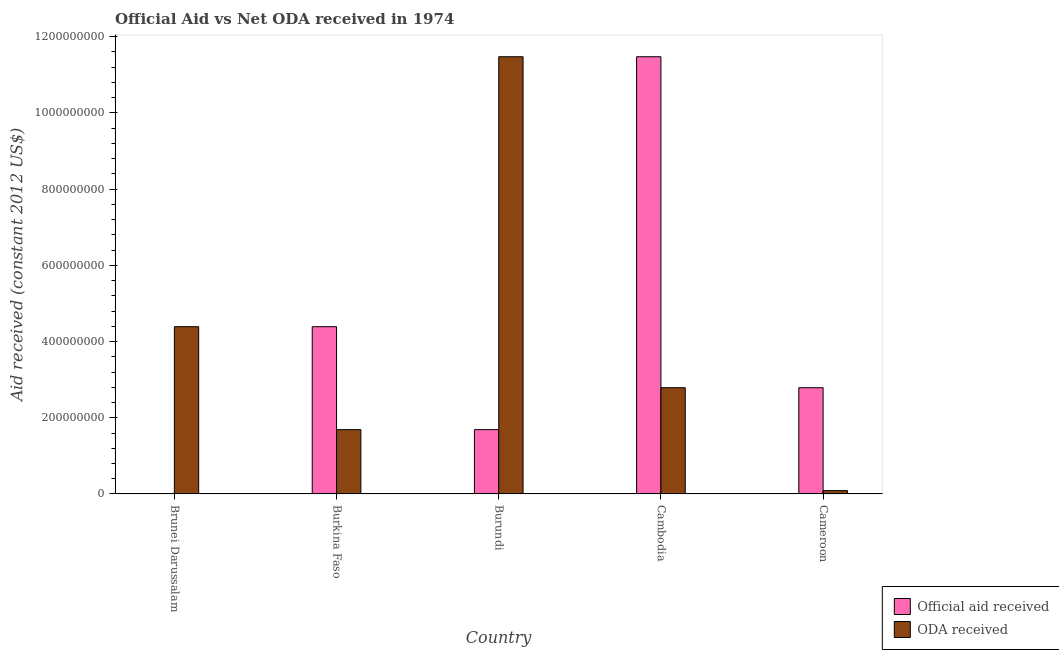How many different coloured bars are there?
Make the answer very short. 2. Are the number of bars per tick equal to the number of legend labels?
Keep it short and to the point. Yes. Are the number of bars on each tick of the X-axis equal?
Your answer should be compact. Yes. How many bars are there on the 5th tick from the left?
Ensure brevity in your answer.  2. What is the label of the 2nd group of bars from the left?
Provide a succinct answer. Burkina Faso. What is the official aid received in Cambodia?
Ensure brevity in your answer.  1.15e+09. Across all countries, what is the maximum oda received?
Keep it short and to the point. 1.15e+09. Across all countries, what is the minimum oda received?
Your response must be concise. 8.77e+06. In which country was the oda received maximum?
Keep it short and to the point. Burundi. In which country was the oda received minimum?
Provide a succinct answer. Cameroon. What is the total oda received in the graph?
Your answer should be compact. 2.04e+09. What is the difference between the official aid received in Burundi and that in Cameroon?
Make the answer very short. -1.10e+08. What is the difference between the official aid received in Cambodia and the oda received in Burundi?
Give a very brief answer. 0. What is the average official aid received per country?
Provide a succinct answer. 4.07e+08. What is the difference between the oda received and official aid received in Burundi?
Provide a succinct answer. 9.79e+08. In how many countries, is the official aid received greater than 880000000 US$?
Give a very brief answer. 1. What is the ratio of the oda received in Burkina Faso to that in Burundi?
Ensure brevity in your answer.  0.15. What is the difference between the highest and the second highest official aid received?
Your answer should be compact. 7.08e+08. What is the difference between the highest and the lowest oda received?
Make the answer very short. 1.14e+09. In how many countries, is the oda received greater than the average oda received taken over all countries?
Keep it short and to the point. 2. What does the 1st bar from the left in Cameroon represents?
Keep it short and to the point. Official aid received. What does the 1st bar from the right in Cambodia represents?
Make the answer very short. ODA received. How many countries are there in the graph?
Make the answer very short. 5. Are the values on the major ticks of Y-axis written in scientific E-notation?
Make the answer very short. No. Where does the legend appear in the graph?
Offer a very short reply. Bottom right. How many legend labels are there?
Offer a terse response. 2. What is the title of the graph?
Keep it short and to the point. Official Aid vs Net ODA received in 1974 . Does "Formally registered" appear as one of the legend labels in the graph?
Make the answer very short. No. What is the label or title of the X-axis?
Provide a succinct answer. Country. What is the label or title of the Y-axis?
Your response must be concise. Aid received (constant 2012 US$). What is the Aid received (constant 2012 US$) in Official aid received in Brunei Darussalam?
Your response must be concise. 7.80e+05. What is the Aid received (constant 2012 US$) in ODA received in Brunei Darussalam?
Ensure brevity in your answer.  4.39e+08. What is the Aid received (constant 2012 US$) in Official aid received in Burkina Faso?
Your answer should be compact. 4.39e+08. What is the Aid received (constant 2012 US$) of ODA received in Burkina Faso?
Your answer should be compact. 1.69e+08. What is the Aid received (constant 2012 US$) in Official aid received in Burundi?
Your response must be concise. 1.69e+08. What is the Aid received (constant 2012 US$) of ODA received in Burundi?
Offer a terse response. 1.15e+09. What is the Aid received (constant 2012 US$) of Official aid received in Cambodia?
Make the answer very short. 1.15e+09. What is the Aid received (constant 2012 US$) in ODA received in Cambodia?
Keep it short and to the point. 2.79e+08. What is the Aid received (constant 2012 US$) of Official aid received in Cameroon?
Offer a very short reply. 2.79e+08. What is the Aid received (constant 2012 US$) of ODA received in Cameroon?
Ensure brevity in your answer.  8.77e+06. Across all countries, what is the maximum Aid received (constant 2012 US$) of Official aid received?
Your answer should be very brief. 1.15e+09. Across all countries, what is the maximum Aid received (constant 2012 US$) of ODA received?
Keep it short and to the point. 1.15e+09. Across all countries, what is the minimum Aid received (constant 2012 US$) of Official aid received?
Give a very brief answer. 7.80e+05. Across all countries, what is the minimum Aid received (constant 2012 US$) in ODA received?
Your response must be concise. 8.77e+06. What is the total Aid received (constant 2012 US$) of Official aid received in the graph?
Offer a terse response. 2.04e+09. What is the total Aid received (constant 2012 US$) of ODA received in the graph?
Offer a terse response. 2.04e+09. What is the difference between the Aid received (constant 2012 US$) in Official aid received in Brunei Darussalam and that in Burkina Faso?
Keep it short and to the point. -4.38e+08. What is the difference between the Aid received (constant 2012 US$) in ODA received in Brunei Darussalam and that in Burkina Faso?
Your answer should be very brief. 2.70e+08. What is the difference between the Aid received (constant 2012 US$) of Official aid received in Brunei Darussalam and that in Burundi?
Your answer should be compact. -1.68e+08. What is the difference between the Aid received (constant 2012 US$) in ODA received in Brunei Darussalam and that in Burundi?
Your answer should be very brief. -7.08e+08. What is the difference between the Aid received (constant 2012 US$) of Official aid received in Brunei Darussalam and that in Cambodia?
Your answer should be compact. -1.15e+09. What is the difference between the Aid received (constant 2012 US$) in ODA received in Brunei Darussalam and that in Cambodia?
Offer a terse response. 1.60e+08. What is the difference between the Aid received (constant 2012 US$) in Official aid received in Brunei Darussalam and that in Cameroon?
Ensure brevity in your answer.  -2.78e+08. What is the difference between the Aid received (constant 2012 US$) in ODA received in Brunei Darussalam and that in Cameroon?
Your answer should be compact. 4.30e+08. What is the difference between the Aid received (constant 2012 US$) in Official aid received in Burkina Faso and that in Burundi?
Offer a terse response. 2.70e+08. What is the difference between the Aid received (constant 2012 US$) of ODA received in Burkina Faso and that in Burundi?
Offer a terse response. -9.79e+08. What is the difference between the Aid received (constant 2012 US$) in Official aid received in Burkina Faso and that in Cambodia?
Offer a very short reply. -7.08e+08. What is the difference between the Aid received (constant 2012 US$) of ODA received in Burkina Faso and that in Cambodia?
Provide a succinct answer. -1.10e+08. What is the difference between the Aid received (constant 2012 US$) of Official aid received in Burkina Faso and that in Cameroon?
Your answer should be compact. 1.60e+08. What is the difference between the Aid received (constant 2012 US$) in ODA received in Burkina Faso and that in Cameroon?
Your response must be concise. 1.60e+08. What is the difference between the Aid received (constant 2012 US$) in Official aid received in Burundi and that in Cambodia?
Your answer should be very brief. -9.79e+08. What is the difference between the Aid received (constant 2012 US$) in ODA received in Burundi and that in Cambodia?
Your answer should be very brief. 8.69e+08. What is the difference between the Aid received (constant 2012 US$) of Official aid received in Burundi and that in Cameroon?
Make the answer very short. -1.10e+08. What is the difference between the Aid received (constant 2012 US$) in ODA received in Burundi and that in Cameroon?
Offer a very short reply. 1.14e+09. What is the difference between the Aid received (constant 2012 US$) of Official aid received in Cambodia and that in Cameroon?
Your response must be concise. 8.69e+08. What is the difference between the Aid received (constant 2012 US$) of ODA received in Cambodia and that in Cameroon?
Your answer should be compact. 2.70e+08. What is the difference between the Aid received (constant 2012 US$) in Official aid received in Brunei Darussalam and the Aid received (constant 2012 US$) in ODA received in Burkina Faso?
Your answer should be very brief. -1.68e+08. What is the difference between the Aid received (constant 2012 US$) in Official aid received in Brunei Darussalam and the Aid received (constant 2012 US$) in ODA received in Burundi?
Your answer should be compact. -1.15e+09. What is the difference between the Aid received (constant 2012 US$) of Official aid received in Brunei Darussalam and the Aid received (constant 2012 US$) of ODA received in Cambodia?
Provide a short and direct response. -2.78e+08. What is the difference between the Aid received (constant 2012 US$) in Official aid received in Brunei Darussalam and the Aid received (constant 2012 US$) in ODA received in Cameroon?
Offer a terse response. -7.99e+06. What is the difference between the Aid received (constant 2012 US$) in Official aid received in Burkina Faso and the Aid received (constant 2012 US$) in ODA received in Burundi?
Your response must be concise. -7.08e+08. What is the difference between the Aid received (constant 2012 US$) in Official aid received in Burkina Faso and the Aid received (constant 2012 US$) in ODA received in Cambodia?
Make the answer very short. 1.60e+08. What is the difference between the Aid received (constant 2012 US$) of Official aid received in Burkina Faso and the Aid received (constant 2012 US$) of ODA received in Cameroon?
Keep it short and to the point. 4.30e+08. What is the difference between the Aid received (constant 2012 US$) of Official aid received in Burundi and the Aid received (constant 2012 US$) of ODA received in Cambodia?
Your answer should be very brief. -1.10e+08. What is the difference between the Aid received (constant 2012 US$) in Official aid received in Burundi and the Aid received (constant 2012 US$) in ODA received in Cameroon?
Your response must be concise. 1.60e+08. What is the difference between the Aid received (constant 2012 US$) of Official aid received in Cambodia and the Aid received (constant 2012 US$) of ODA received in Cameroon?
Provide a succinct answer. 1.14e+09. What is the average Aid received (constant 2012 US$) of Official aid received per country?
Provide a short and direct response. 4.07e+08. What is the average Aid received (constant 2012 US$) in ODA received per country?
Give a very brief answer. 4.09e+08. What is the difference between the Aid received (constant 2012 US$) of Official aid received and Aid received (constant 2012 US$) of ODA received in Brunei Darussalam?
Your response must be concise. -4.38e+08. What is the difference between the Aid received (constant 2012 US$) in Official aid received and Aid received (constant 2012 US$) in ODA received in Burkina Faso?
Your answer should be very brief. 2.70e+08. What is the difference between the Aid received (constant 2012 US$) of Official aid received and Aid received (constant 2012 US$) of ODA received in Burundi?
Offer a terse response. -9.79e+08. What is the difference between the Aid received (constant 2012 US$) in Official aid received and Aid received (constant 2012 US$) in ODA received in Cambodia?
Give a very brief answer. 8.69e+08. What is the difference between the Aid received (constant 2012 US$) in Official aid received and Aid received (constant 2012 US$) in ODA received in Cameroon?
Provide a succinct answer. 2.70e+08. What is the ratio of the Aid received (constant 2012 US$) of Official aid received in Brunei Darussalam to that in Burkina Faso?
Offer a terse response. 0. What is the ratio of the Aid received (constant 2012 US$) of Official aid received in Brunei Darussalam to that in Burundi?
Provide a short and direct response. 0. What is the ratio of the Aid received (constant 2012 US$) of ODA received in Brunei Darussalam to that in Burundi?
Provide a short and direct response. 0.38. What is the ratio of the Aid received (constant 2012 US$) in Official aid received in Brunei Darussalam to that in Cambodia?
Give a very brief answer. 0. What is the ratio of the Aid received (constant 2012 US$) of ODA received in Brunei Darussalam to that in Cambodia?
Give a very brief answer. 1.57. What is the ratio of the Aid received (constant 2012 US$) of Official aid received in Brunei Darussalam to that in Cameroon?
Offer a very short reply. 0. What is the ratio of the Aid received (constant 2012 US$) in ODA received in Brunei Darussalam to that in Cameroon?
Your answer should be very brief. 50.06. What is the ratio of the Aid received (constant 2012 US$) of ODA received in Burkina Faso to that in Burundi?
Ensure brevity in your answer.  0.15. What is the ratio of the Aid received (constant 2012 US$) in Official aid received in Burkina Faso to that in Cambodia?
Give a very brief answer. 0.38. What is the ratio of the Aid received (constant 2012 US$) of ODA received in Burkina Faso to that in Cambodia?
Provide a succinct answer. 0.61. What is the ratio of the Aid received (constant 2012 US$) in Official aid received in Burkina Faso to that in Cameroon?
Provide a succinct answer. 1.57. What is the ratio of the Aid received (constant 2012 US$) in ODA received in Burkina Faso to that in Cameroon?
Your answer should be very brief. 19.25. What is the ratio of the Aid received (constant 2012 US$) in Official aid received in Burundi to that in Cambodia?
Make the answer very short. 0.15. What is the ratio of the Aid received (constant 2012 US$) in ODA received in Burundi to that in Cambodia?
Provide a short and direct response. 4.12. What is the ratio of the Aid received (constant 2012 US$) in Official aid received in Burundi to that in Cameroon?
Provide a succinct answer. 0.61. What is the ratio of the Aid received (constant 2012 US$) in ODA received in Burundi to that in Cameroon?
Provide a succinct answer. 130.84. What is the ratio of the Aid received (constant 2012 US$) of Official aid received in Cambodia to that in Cameroon?
Your response must be concise. 4.12. What is the ratio of the Aid received (constant 2012 US$) of ODA received in Cambodia to that in Cameroon?
Ensure brevity in your answer.  31.8. What is the difference between the highest and the second highest Aid received (constant 2012 US$) of Official aid received?
Ensure brevity in your answer.  7.08e+08. What is the difference between the highest and the second highest Aid received (constant 2012 US$) in ODA received?
Offer a terse response. 7.08e+08. What is the difference between the highest and the lowest Aid received (constant 2012 US$) of Official aid received?
Keep it short and to the point. 1.15e+09. What is the difference between the highest and the lowest Aid received (constant 2012 US$) of ODA received?
Give a very brief answer. 1.14e+09. 